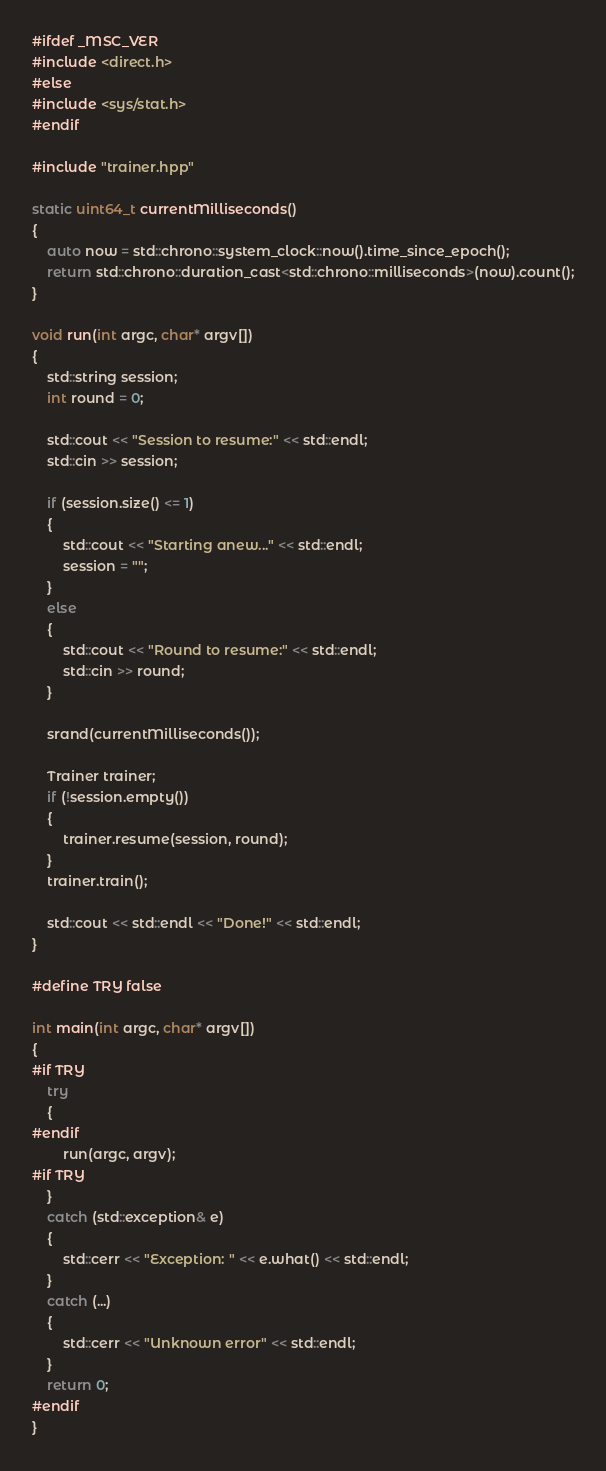<code> <loc_0><loc_0><loc_500><loc_500><_C++_>#ifdef _MSC_VER
#include <direct.h>
#else
#include <sys/stat.h>
#endif

#include "trainer.hpp"

static uint64_t currentMilliseconds()
{
	auto now = std::chrono::system_clock::now().time_since_epoch();
	return std::chrono::duration_cast<std::chrono::milliseconds>(now).count();
}

void run(int argc, char* argv[])
{
	std::string session;
	int round = 0;

	std::cout << "Session to resume:" << std::endl;
	std::cin >> session;

	if (session.size() <= 1)
	{
		std::cout << "Starting anew..." << std::endl;
		session = "";
	}
	else
	{
		std::cout << "Round to resume:" << std::endl;
		std::cin >> round;
	}

	srand(currentMilliseconds());

	Trainer trainer;
	if (!session.empty())
	{
		trainer.resume(session, round);
	}
	trainer.train();

	std::cout << std::endl << "Done!" << std::endl;
}

#define TRY false

int main(int argc, char* argv[])
{
#if TRY
	try
	{
#endif
		run(argc, argv);
#if TRY
	}
	catch (std::exception& e)
	{
		std::cerr << "Exception: " << e.what() << std::endl;
	}
	catch (...)
	{
		std::cerr << "Unknown error" << std::endl;
	}
	return 0;
#endif
}
</code> 